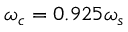<formula> <loc_0><loc_0><loc_500><loc_500>\omega _ { c } = 0 . 9 2 5 \omega _ { s }</formula> 